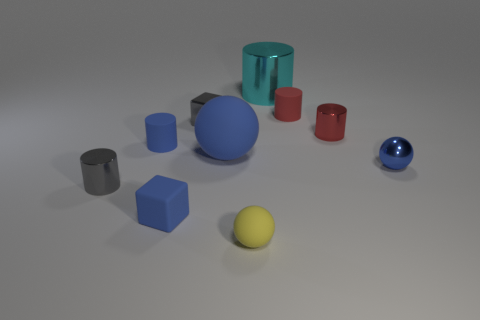Is the material of the small gray object that is in front of the big matte thing the same as the tiny blue sphere? While the image shows objects that seem to have different textures and reflections, without the ability to analyze the material composition directly, we can speculate that the small gray object and the tiny blue sphere may not be made of the same material. They exhibit different appearances, like their colors and surface qualities, suggesting they could be composed of various substances. 